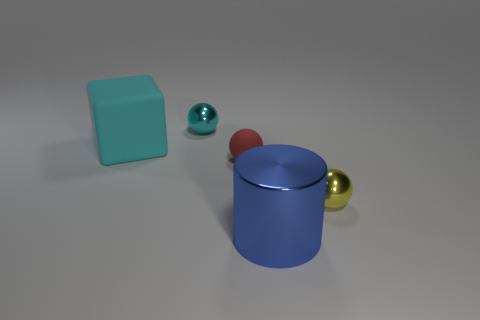What number of cyan things are there?
Give a very brief answer. 2. Do the rubber block and the yellow sphere have the same size?
Offer a very short reply. No. What number of other objects are there of the same shape as the big metallic object?
Make the answer very short. 0. What material is the object that is in front of the thing right of the blue metal thing made of?
Offer a terse response. Metal. Are there any red matte balls on the right side of the big metallic object?
Provide a succinct answer. No. There is a yellow object; is its size the same as the metallic sphere left of the large metallic cylinder?
Offer a very short reply. Yes. There is a yellow object that is the same shape as the tiny cyan thing; what is its size?
Your answer should be very brief. Small. Is there any other thing that has the same material as the big cylinder?
Your response must be concise. Yes. There is a cyan thing that is to the right of the big cyan thing; is its size the same as the sphere in front of the tiny red rubber thing?
Ensure brevity in your answer.  Yes. What number of large things are yellow metallic objects or metal cylinders?
Ensure brevity in your answer.  1. 